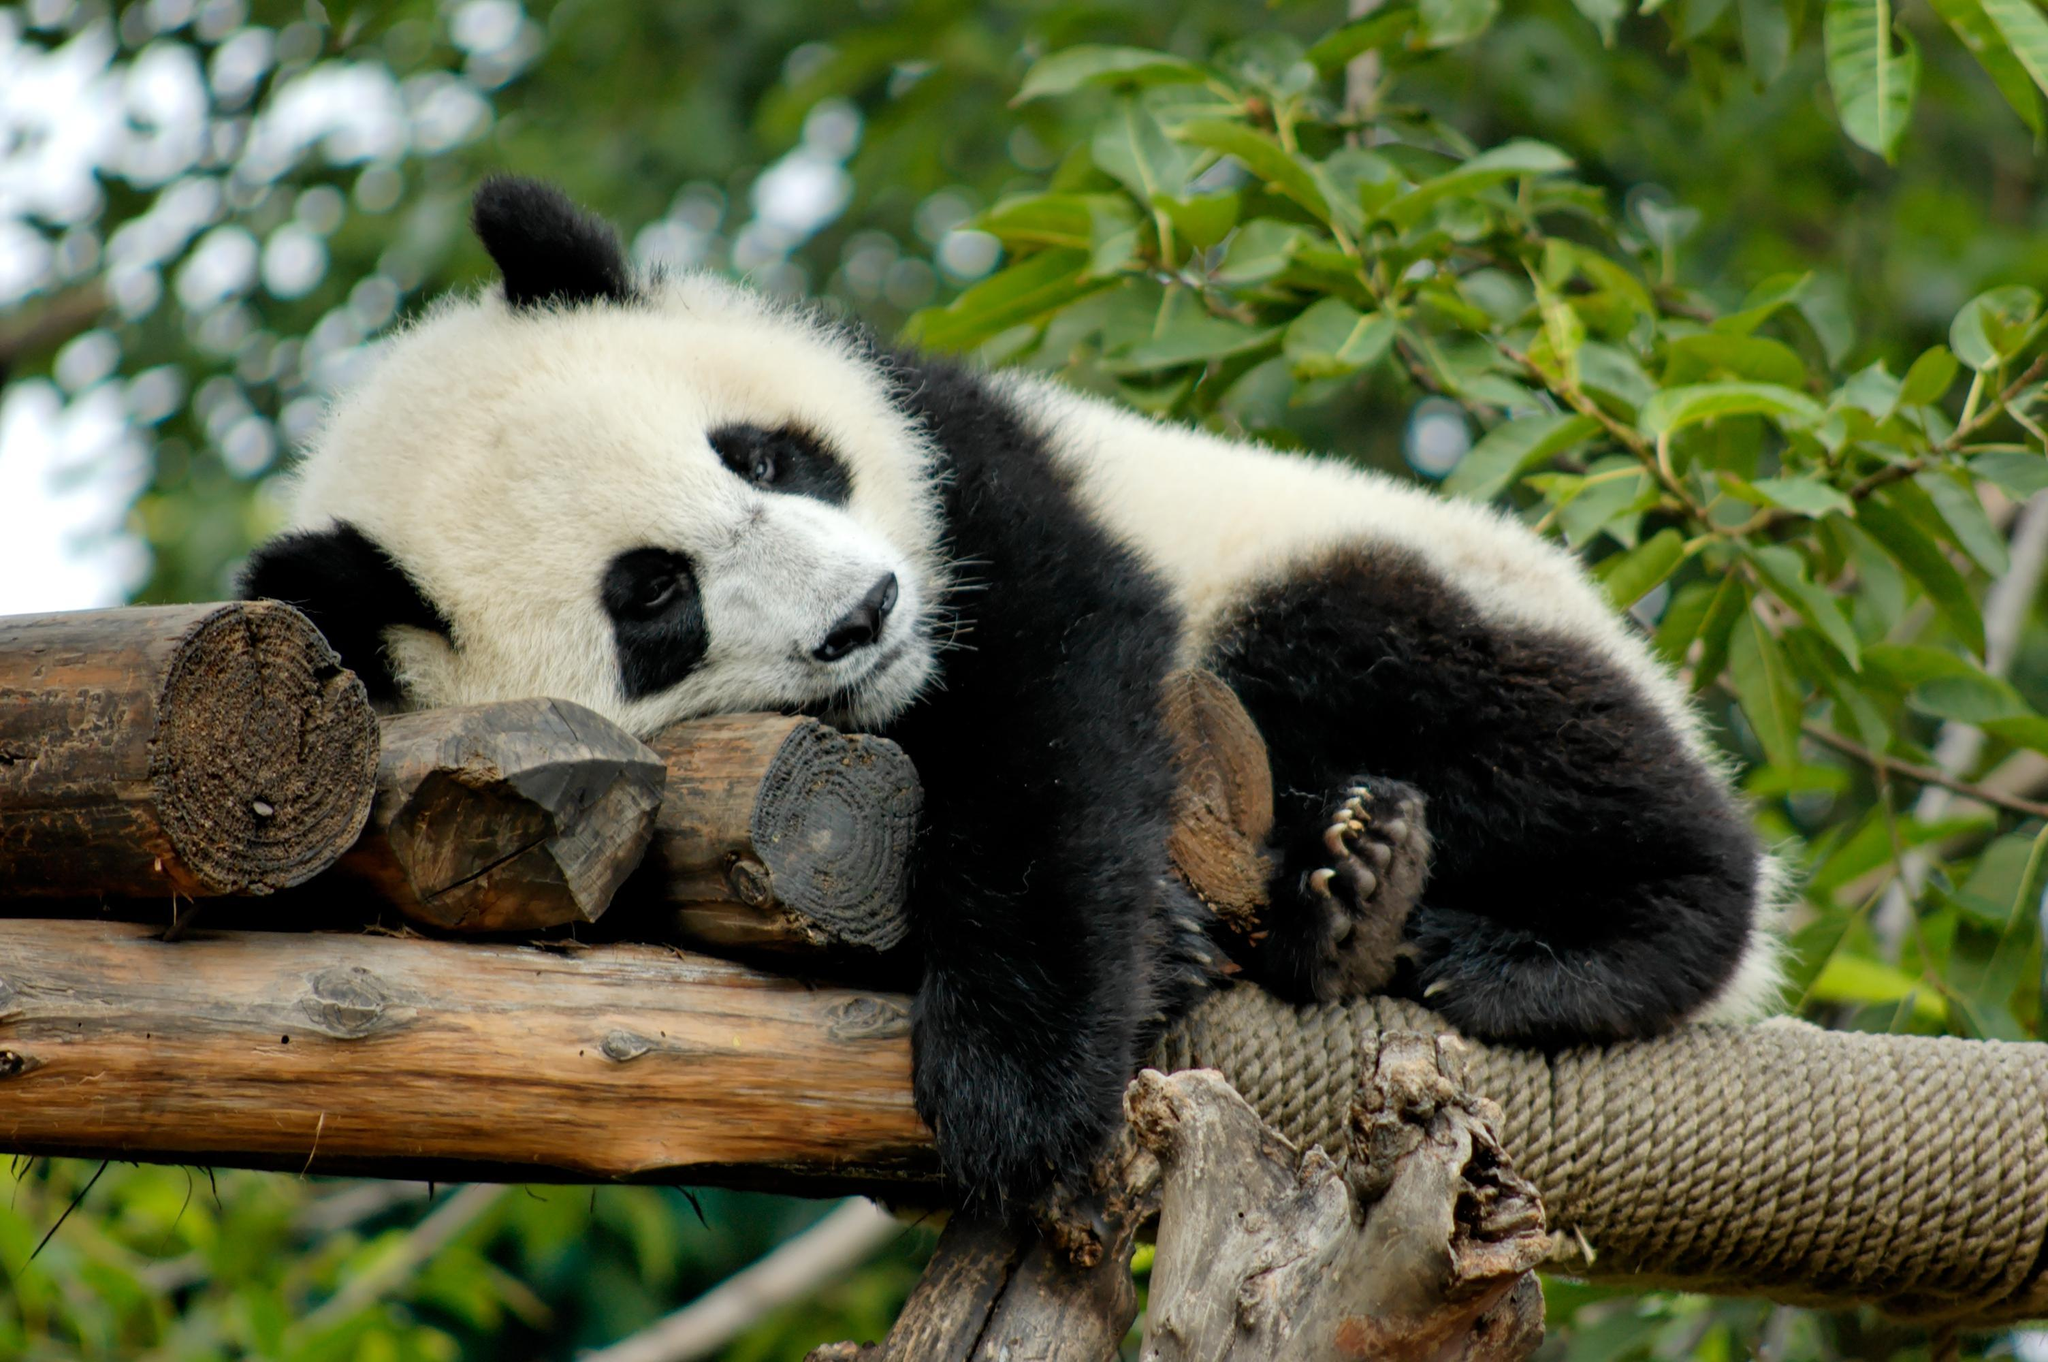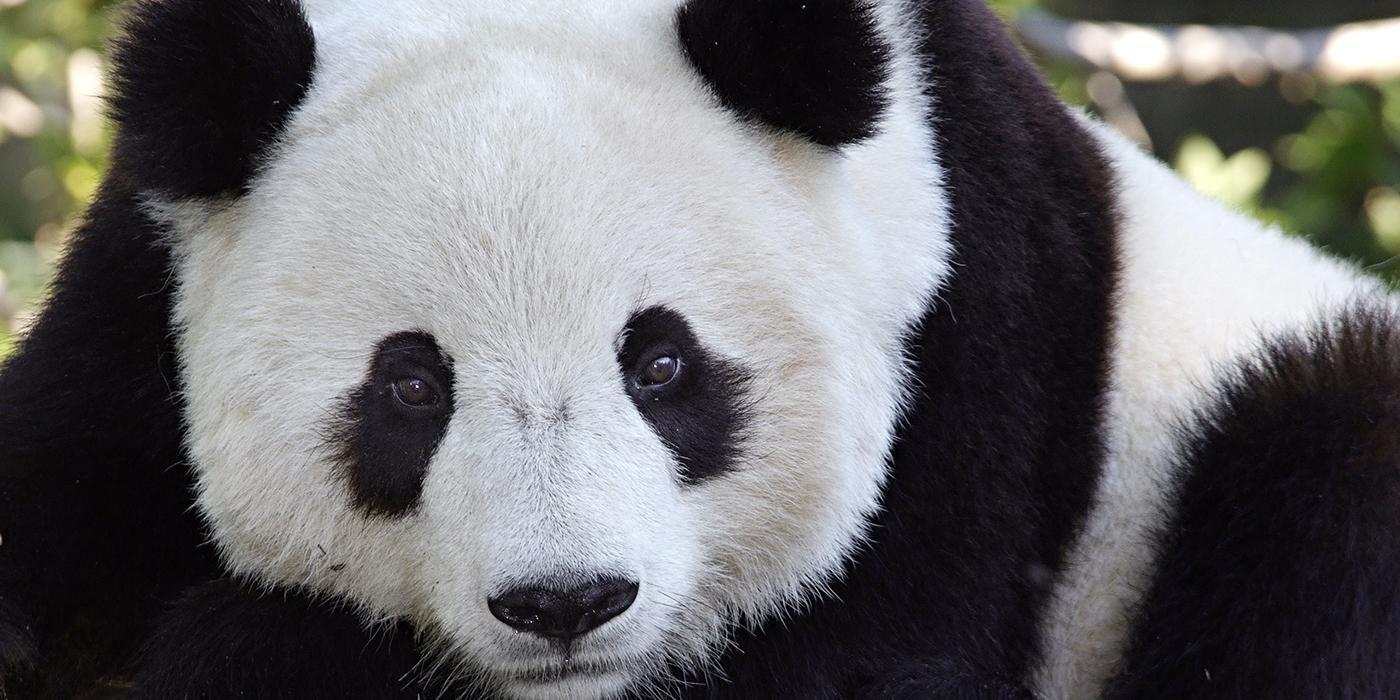The first image is the image on the left, the second image is the image on the right. Evaluate the accuracy of this statement regarding the images: "Both of one panda's front paws are extended forward and visible.". Is it true? Answer yes or no. No. 